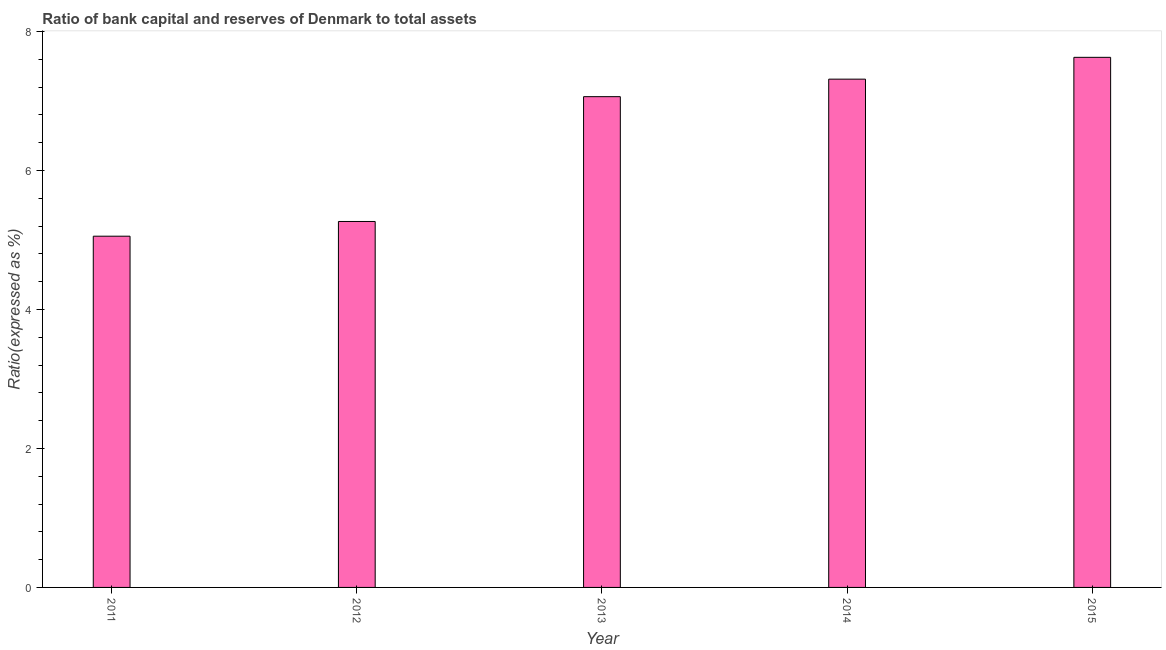What is the title of the graph?
Keep it short and to the point. Ratio of bank capital and reserves of Denmark to total assets. What is the label or title of the X-axis?
Make the answer very short. Year. What is the label or title of the Y-axis?
Offer a terse response. Ratio(expressed as %). What is the bank capital to assets ratio in 2013?
Provide a succinct answer. 7.06. Across all years, what is the maximum bank capital to assets ratio?
Provide a succinct answer. 7.63. Across all years, what is the minimum bank capital to assets ratio?
Offer a terse response. 5.05. In which year was the bank capital to assets ratio maximum?
Give a very brief answer. 2015. What is the sum of the bank capital to assets ratio?
Offer a very short reply. 32.32. What is the difference between the bank capital to assets ratio in 2013 and 2014?
Offer a terse response. -0.25. What is the average bank capital to assets ratio per year?
Offer a terse response. 6.46. What is the median bank capital to assets ratio?
Your answer should be very brief. 7.06. What is the ratio of the bank capital to assets ratio in 2012 to that in 2015?
Your answer should be compact. 0.69. What is the difference between the highest and the second highest bank capital to assets ratio?
Your response must be concise. 0.31. What is the difference between the highest and the lowest bank capital to assets ratio?
Provide a short and direct response. 2.57. How many bars are there?
Keep it short and to the point. 5. How many years are there in the graph?
Provide a succinct answer. 5. Are the values on the major ticks of Y-axis written in scientific E-notation?
Your answer should be compact. No. What is the Ratio(expressed as %) of 2011?
Your response must be concise. 5.05. What is the Ratio(expressed as %) of 2012?
Provide a succinct answer. 5.27. What is the Ratio(expressed as %) of 2013?
Offer a very short reply. 7.06. What is the Ratio(expressed as %) of 2014?
Ensure brevity in your answer.  7.31. What is the Ratio(expressed as %) of 2015?
Give a very brief answer. 7.63. What is the difference between the Ratio(expressed as %) in 2011 and 2012?
Your answer should be compact. -0.21. What is the difference between the Ratio(expressed as %) in 2011 and 2013?
Offer a terse response. -2.01. What is the difference between the Ratio(expressed as %) in 2011 and 2014?
Your response must be concise. -2.26. What is the difference between the Ratio(expressed as %) in 2011 and 2015?
Provide a succinct answer. -2.57. What is the difference between the Ratio(expressed as %) in 2012 and 2013?
Offer a very short reply. -1.8. What is the difference between the Ratio(expressed as %) in 2012 and 2014?
Ensure brevity in your answer.  -2.05. What is the difference between the Ratio(expressed as %) in 2012 and 2015?
Your response must be concise. -2.36. What is the difference between the Ratio(expressed as %) in 2013 and 2014?
Provide a succinct answer. -0.25. What is the difference between the Ratio(expressed as %) in 2013 and 2015?
Your answer should be very brief. -0.57. What is the difference between the Ratio(expressed as %) in 2014 and 2015?
Provide a short and direct response. -0.31. What is the ratio of the Ratio(expressed as %) in 2011 to that in 2012?
Your response must be concise. 0.96. What is the ratio of the Ratio(expressed as %) in 2011 to that in 2013?
Your answer should be compact. 0.72. What is the ratio of the Ratio(expressed as %) in 2011 to that in 2014?
Provide a succinct answer. 0.69. What is the ratio of the Ratio(expressed as %) in 2011 to that in 2015?
Provide a short and direct response. 0.66. What is the ratio of the Ratio(expressed as %) in 2012 to that in 2013?
Your answer should be compact. 0.75. What is the ratio of the Ratio(expressed as %) in 2012 to that in 2014?
Ensure brevity in your answer.  0.72. What is the ratio of the Ratio(expressed as %) in 2012 to that in 2015?
Provide a succinct answer. 0.69. What is the ratio of the Ratio(expressed as %) in 2013 to that in 2014?
Offer a terse response. 0.97. What is the ratio of the Ratio(expressed as %) in 2013 to that in 2015?
Ensure brevity in your answer.  0.93. What is the ratio of the Ratio(expressed as %) in 2014 to that in 2015?
Give a very brief answer. 0.96. 